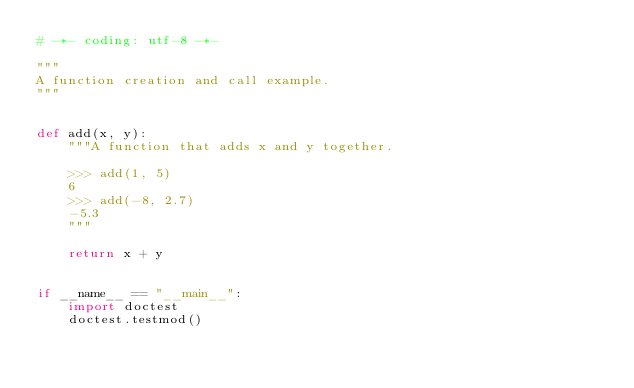<code> <loc_0><loc_0><loc_500><loc_500><_Python_># -*- coding: utf-8 -*-

"""
A function creation and call example.
"""


def add(x, y):
    """A function that adds x and y together.

    >>> add(1, 5)
    6
    >>> add(-8, 2.7)
    -5.3
    """

    return x + y


if __name__ == "__main__":
    import doctest
    doctest.testmod()
</code> 